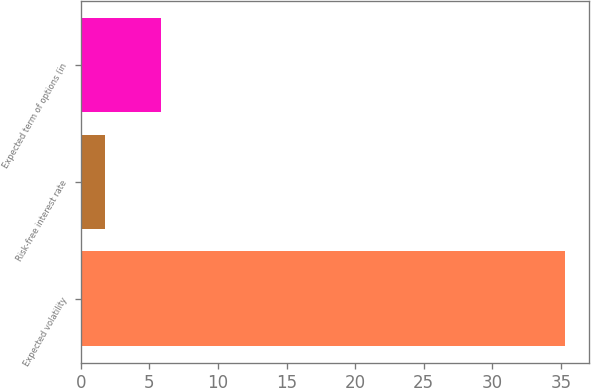Convert chart. <chart><loc_0><loc_0><loc_500><loc_500><bar_chart><fcel>Expected volatility<fcel>Risk-free interest rate<fcel>Expected term of options (in<nl><fcel>35.3<fcel>1.76<fcel>5.82<nl></chart> 